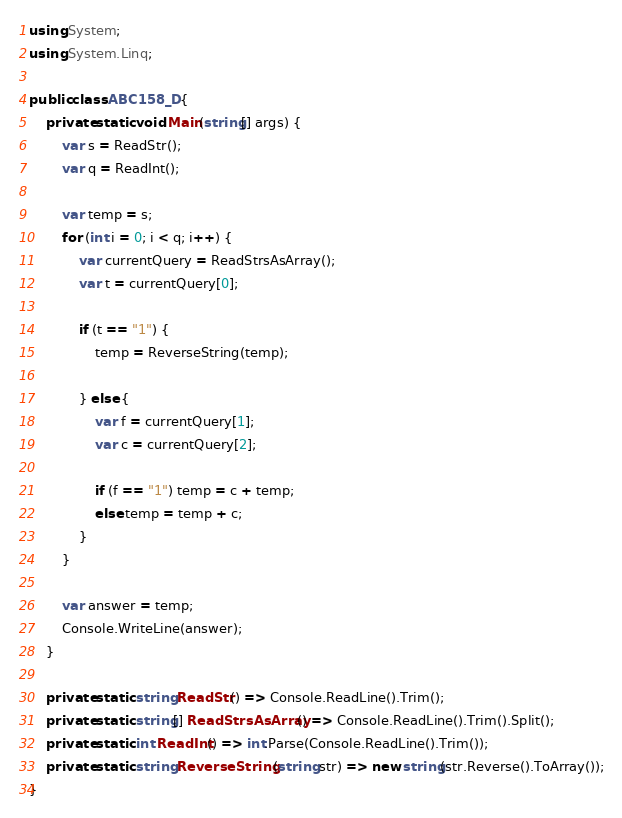<code> <loc_0><loc_0><loc_500><loc_500><_C#_>using System;
using System.Linq;

public class ABC158_D {
	private static void Main(string[] args) {
		var s = ReadStr();
		var q = ReadInt();

		var temp = s;
		for (int i = 0; i < q; i++) {
			var currentQuery = ReadStrsAsArray();
			var t = currentQuery[0];

			if (t == "1") {
				temp = ReverseString(temp);

			} else {
				var f = currentQuery[1];
				var c = currentQuery[2];

				if (f == "1") temp = c + temp;
				else temp = temp + c;
			}
		}

		var answer = temp;
		Console.WriteLine(answer);
	}

	private static string ReadStr() => Console.ReadLine().Trim();
	private static string[] ReadStrsAsArray() => Console.ReadLine().Trim().Split();
	private static int ReadInt() => int.Parse(Console.ReadLine().Trim());
	private static string ReverseString (string str) => new string(str.Reverse().ToArray());
}</code> 